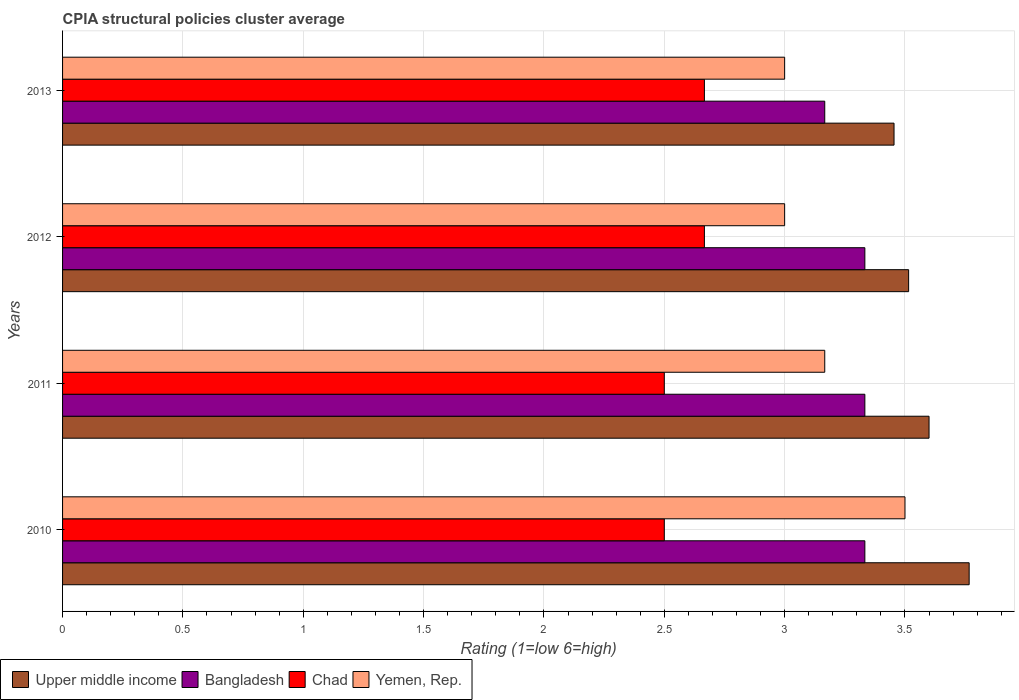How many different coloured bars are there?
Your answer should be compact. 4. How many bars are there on the 4th tick from the bottom?
Provide a succinct answer. 4. What is the label of the 2nd group of bars from the top?
Ensure brevity in your answer.  2012. What is the CPIA rating in Upper middle income in 2013?
Provide a succinct answer. 3.45. Across all years, what is the maximum CPIA rating in Yemen, Rep.?
Your response must be concise. 3.5. Across all years, what is the minimum CPIA rating in Yemen, Rep.?
Your answer should be compact. 3. In which year was the CPIA rating in Yemen, Rep. minimum?
Your answer should be compact. 2012. What is the total CPIA rating in Yemen, Rep. in the graph?
Offer a terse response. 12.67. What is the difference between the CPIA rating in Chad in 2010 and that in 2013?
Keep it short and to the point. -0.17. What is the difference between the CPIA rating in Bangladesh in 2013 and the CPIA rating in Chad in 2012?
Give a very brief answer. 0.5. What is the average CPIA rating in Yemen, Rep. per year?
Make the answer very short. 3.17. In the year 2011, what is the difference between the CPIA rating in Upper middle income and CPIA rating in Chad?
Keep it short and to the point. 1.1. What is the ratio of the CPIA rating in Upper middle income in 2010 to that in 2013?
Offer a terse response. 1.09. Is the CPIA rating in Chad in 2011 less than that in 2012?
Your answer should be very brief. Yes. What is the difference between the highest and the second highest CPIA rating in Chad?
Provide a short and direct response. 0. What is the difference between the highest and the lowest CPIA rating in Bangladesh?
Provide a succinct answer. 0.17. Is the sum of the CPIA rating in Bangladesh in 2012 and 2013 greater than the maximum CPIA rating in Chad across all years?
Ensure brevity in your answer.  Yes. What does the 1st bar from the top in 2010 represents?
Offer a very short reply. Yemen, Rep. Are all the bars in the graph horizontal?
Your response must be concise. Yes. How many years are there in the graph?
Your answer should be very brief. 4. How are the legend labels stacked?
Give a very brief answer. Horizontal. What is the title of the graph?
Offer a very short reply. CPIA structural policies cluster average. Does "Botswana" appear as one of the legend labels in the graph?
Your response must be concise. No. What is the label or title of the X-axis?
Make the answer very short. Rating (1=low 6=high). What is the Rating (1=low 6=high) in Upper middle income in 2010?
Your answer should be compact. 3.77. What is the Rating (1=low 6=high) of Bangladesh in 2010?
Make the answer very short. 3.33. What is the Rating (1=low 6=high) in Chad in 2010?
Provide a succinct answer. 2.5. What is the Rating (1=low 6=high) of Upper middle income in 2011?
Give a very brief answer. 3.6. What is the Rating (1=low 6=high) in Bangladesh in 2011?
Make the answer very short. 3.33. What is the Rating (1=low 6=high) in Chad in 2011?
Offer a terse response. 2.5. What is the Rating (1=low 6=high) in Yemen, Rep. in 2011?
Ensure brevity in your answer.  3.17. What is the Rating (1=low 6=high) of Upper middle income in 2012?
Your response must be concise. 3.52. What is the Rating (1=low 6=high) in Bangladesh in 2012?
Make the answer very short. 3.33. What is the Rating (1=low 6=high) in Chad in 2012?
Your answer should be compact. 2.67. What is the Rating (1=low 6=high) in Yemen, Rep. in 2012?
Provide a succinct answer. 3. What is the Rating (1=low 6=high) of Upper middle income in 2013?
Your response must be concise. 3.45. What is the Rating (1=low 6=high) of Bangladesh in 2013?
Ensure brevity in your answer.  3.17. What is the Rating (1=low 6=high) in Chad in 2013?
Offer a terse response. 2.67. What is the Rating (1=low 6=high) in Yemen, Rep. in 2013?
Keep it short and to the point. 3. Across all years, what is the maximum Rating (1=low 6=high) of Upper middle income?
Provide a succinct answer. 3.77. Across all years, what is the maximum Rating (1=low 6=high) of Bangladesh?
Your response must be concise. 3.33. Across all years, what is the maximum Rating (1=low 6=high) in Chad?
Ensure brevity in your answer.  2.67. Across all years, what is the minimum Rating (1=low 6=high) in Upper middle income?
Offer a very short reply. 3.45. Across all years, what is the minimum Rating (1=low 6=high) in Bangladesh?
Provide a succinct answer. 3.17. Across all years, what is the minimum Rating (1=low 6=high) of Chad?
Offer a terse response. 2.5. What is the total Rating (1=low 6=high) of Upper middle income in the graph?
Keep it short and to the point. 14.34. What is the total Rating (1=low 6=high) in Bangladesh in the graph?
Offer a terse response. 13.17. What is the total Rating (1=low 6=high) in Chad in the graph?
Ensure brevity in your answer.  10.33. What is the total Rating (1=low 6=high) of Yemen, Rep. in the graph?
Keep it short and to the point. 12.67. What is the difference between the Rating (1=low 6=high) of Yemen, Rep. in 2010 and that in 2011?
Keep it short and to the point. 0.33. What is the difference between the Rating (1=low 6=high) of Upper middle income in 2010 and that in 2012?
Make the answer very short. 0.25. What is the difference between the Rating (1=low 6=high) of Bangladesh in 2010 and that in 2012?
Your answer should be compact. 0. What is the difference between the Rating (1=low 6=high) in Chad in 2010 and that in 2012?
Offer a terse response. -0.17. What is the difference between the Rating (1=low 6=high) in Yemen, Rep. in 2010 and that in 2012?
Provide a succinct answer. 0.5. What is the difference between the Rating (1=low 6=high) of Upper middle income in 2010 and that in 2013?
Make the answer very short. 0.31. What is the difference between the Rating (1=low 6=high) of Bangladesh in 2010 and that in 2013?
Make the answer very short. 0.17. What is the difference between the Rating (1=low 6=high) of Upper middle income in 2011 and that in 2012?
Offer a terse response. 0.08. What is the difference between the Rating (1=low 6=high) of Chad in 2011 and that in 2012?
Provide a short and direct response. -0.17. What is the difference between the Rating (1=low 6=high) in Yemen, Rep. in 2011 and that in 2012?
Provide a short and direct response. 0.17. What is the difference between the Rating (1=low 6=high) in Upper middle income in 2011 and that in 2013?
Your answer should be very brief. 0.15. What is the difference between the Rating (1=low 6=high) in Chad in 2011 and that in 2013?
Give a very brief answer. -0.17. What is the difference between the Rating (1=low 6=high) of Yemen, Rep. in 2011 and that in 2013?
Give a very brief answer. 0.17. What is the difference between the Rating (1=low 6=high) in Upper middle income in 2012 and that in 2013?
Your answer should be compact. 0.06. What is the difference between the Rating (1=low 6=high) of Bangladesh in 2012 and that in 2013?
Your answer should be very brief. 0.17. What is the difference between the Rating (1=low 6=high) of Chad in 2012 and that in 2013?
Offer a very short reply. 0. What is the difference between the Rating (1=low 6=high) in Yemen, Rep. in 2012 and that in 2013?
Your answer should be very brief. 0. What is the difference between the Rating (1=low 6=high) in Upper middle income in 2010 and the Rating (1=low 6=high) in Bangladesh in 2011?
Your response must be concise. 0.43. What is the difference between the Rating (1=low 6=high) of Upper middle income in 2010 and the Rating (1=low 6=high) of Chad in 2011?
Your answer should be very brief. 1.27. What is the difference between the Rating (1=low 6=high) of Upper middle income in 2010 and the Rating (1=low 6=high) of Yemen, Rep. in 2011?
Your answer should be very brief. 0.6. What is the difference between the Rating (1=low 6=high) of Bangladesh in 2010 and the Rating (1=low 6=high) of Chad in 2011?
Your answer should be very brief. 0.83. What is the difference between the Rating (1=low 6=high) in Upper middle income in 2010 and the Rating (1=low 6=high) in Bangladesh in 2012?
Your answer should be very brief. 0.43. What is the difference between the Rating (1=low 6=high) in Upper middle income in 2010 and the Rating (1=low 6=high) in Chad in 2012?
Provide a succinct answer. 1.1. What is the difference between the Rating (1=low 6=high) in Upper middle income in 2010 and the Rating (1=low 6=high) in Yemen, Rep. in 2012?
Your answer should be compact. 0.77. What is the difference between the Rating (1=low 6=high) in Bangladesh in 2010 and the Rating (1=low 6=high) in Yemen, Rep. in 2012?
Your answer should be compact. 0.33. What is the difference between the Rating (1=low 6=high) of Upper middle income in 2010 and the Rating (1=low 6=high) of Bangladesh in 2013?
Keep it short and to the point. 0.6. What is the difference between the Rating (1=low 6=high) in Upper middle income in 2010 and the Rating (1=low 6=high) in Chad in 2013?
Keep it short and to the point. 1.1. What is the difference between the Rating (1=low 6=high) in Upper middle income in 2010 and the Rating (1=low 6=high) in Yemen, Rep. in 2013?
Provide a short and direct response. 0.77. What is the difference between the Rating (1=low 6=high) in Bangladesh in 2010 and the Rating (1=low 6=high) in Chad in 2013?
Offer a terse response. 0.67. What is the difference between the Rating (1=low 6=high) in Chad in 2010 and the Rating (1=low 6=high) in Yemen, Rep. in 2013?
Keep it short and to the point. -0.5. What is the difference between the Rating (1=low 6=high) of Upper middle income in 2011 and the Rating (1=low 6=high) of Bangladesh in 2012?
Offer a terse response. 0.27. What is the difference between the Rating (1=low 6=high) in Upper middle income in 2011 and the Rating (1=low 6=high) in Yemen, Rep. in 2012?
Ensure brevity in your answer.  0.6. What is the difference between the Rating (1=low 6=high) of Bangladesh in 2011 and the Rating (1=low 6=high) of Chad in 2012?
Keep it short and to the point. 0.67. What is the difference between the Rating (1=low 6=high) in Bangladesh in 2011 and the Rating (1=low 6=high) in Yemen, Rep. in 2012?
Make the answer very short. 0.33. What is the difference between the Rating (1=low 6=high) of Chad in 2011 and the Rating (1=low 6=high) of Yemen, Rep. in 2012?
Give a very brief answer. -0.5. What is the difference between the Rating (1=low 6=high) of Upper middle income in 2011 and the Rating (1=low 6=high) of Bangladesh in 2013?
Keep it short and to the point. 0.43. What is the difference between the Rating (1=low 6=high) in Upper middle income in 2011 and the Rating (1=low 6=high) in Chad in 2013?
Provide a succinct answer. 0.93. What is the difference between the Rating (1=low 6=high) in Upper middle income in 2012 and the Rating (1=low 6=high) in Bangladesh in 2013?
Keep it short and to the point. 0.35. What is the difference between the Rating (1=low 6=high) in Upper middle income in 2012 and the Rating (1=low 6=high) in Chad in 2013?
Provide a succinct answer. 0.85. What is the difference between the Rating (1=low 6=high) of Upper middle income in 2012 and the Rating (1=low 6=high) of Yemen, Rep. in 2013?
Your response must be concise. 0.52. What is the difference between the Rating (1=low 6=high) of Bangladesh in 2012 and the Rating (1=low 6=high) of Yemen, Rep. in 2013?
Offer a very short reply. 0.33. What is the difference between the Rating (1=low 6=high) in Chad in 2012 and the Rating (1=low 6=high) in Yemen, Rep. in 2013?
Provide a succinct answer. -0.33. What is the average Rating (1=low 6=high) of Upper middle income per year?
Provide a short and direct response. 3.58. What is the average Rating (1=low 6=high) in Bangladesh per year?
Your answer should be compact. 3.29. What is the average Rating (1=low 6=high) in Chad per year?
Provide a succinct answer. 2.58. What is the average Rating (1=low 6=high) of Yemen, Rep. per year?
Offer a very short reply. 3.17. In the year 2010, what is the difference between the Rating (1=low 6=high) of Upper middle income and Rating (1=low 6=high) of Bangladesh?
Give a very brief answer. 0.43. In the year 2010, what is the difference between the Rating (1=low 6=high) of Upper middle income and Rating (1=low 6=high) of Chad?
Your response must be concise. 1.27. In the year 2010, what is the difference between the Rating (1=low 6=high) in Upper middle income and Rating (1=low 6=high) in Yemen, Rep.?
Your answer should be compact. 0.27. In the year 2011, what is the difference between the Rating (1=low 6=high) of Upper middle income and Rating (1=low 6=high) of Bangladesh?
Provide a short and direct response. 0.27. In the year 2011, what is the difference between the Rating (1=low 6=high) in Upper middle income and Rating (1=low 6=high) in Chad?
Offer a very short reply. 1.1. In the year 2011, what is the difference between the Rating (1=low 6=high) in Upper middle income and Rating (1=low 6=high) in Yemen, Rep.?
Give a very brief answer. 0.43. In the year 2012, what is the difference between the Rating (1=low 6=high) of Upper middle income and Rating (1=low 6=high) of Bangladesh?
Your answer should be very brief. 0.18. In the year 2012, what is the difference between the Rating (1=low 6=high) in Upper middle income and Rating (1=low 6=high) in Chad?
Offer a terse response. 0.85. In the year 2012, what is the difference between the Rating (1=low 6=high) in Upper middle income and Rating (1=low 6=high) in Yemen, Rep.?
Your answer should be compact. 0.52. In the year 2012, what is the difference between the Rating (1=low 6=high) of Bangladesh and Rating (1=low 6=high) of Yemen, Rep.?
Give a very brief answer. 0.33. In the year 2013, what is the difference between the Rating (1=low 6=high) of Upper middle income and Rating (1=low 6=high) of Bangladesh?
Your answer should be very brief. 0.29. In the year 2013, what is the difference between the Rating (1=low 6=high) in Upper middle income and Rating (1=low 6=high) in Chad?
Your answer should be compact. 0.79. In the year 2013, what is the difference between the Rating (1=low 6=high) in Upper middle income and Rating (1=low 6=high) in Yemen, Rep.?
Your answer should be compact. 0.45. In the year 2013, what is the difference between the Rating (1=low 6=high) of Bangladesh and Rating (1=low 6=high) of Chad?
Provide a succinct answer. 0.5. What is the ratio of the Rating (1=low 6=high) in Upper middle income in 2010 to that in 2011?
Your answer should be very brief. 1.05. What is the ratio of the Rating (1=low 6=high) in Chad in 2010 to that in 2011?
Your response must be concise. 1. What is the ratio of the Rating (1=low 6=high) of Yemen, Rep. in 2010 to that in 2011?
Your answer should be compact. 1.11. What is the ratio of the Rating (1=low 6=high) of Upper middle income in 2010 to that in 2012?
Offer a terse response. 1.07. What is the ratio of the Rating (1=low 6=high) of Upper middle income in 2010 to that in 2013?
Provide a succinct answer. 1.09. What is the ratio of the Rating (1=low 6=high) of Bangladesh in 2010 to that in 2013?
Give a very brief answer. 1.05. What is the ratio of the Rating (1=low 6=high) in Upper middle income in 2011 to that in 2012?
Provide a succinct answer. 1.02. What is the ratio of the Rating (1=low 6=high) in Bangladesh in 2011 to that in 2012?
Provide a succinct answer. 1. What is the ratio of the Rating (1=low 6=high) in Chad in 2011 to that in 2012?
Provide a short and direct response. 0.94. What is the ratio of the Rating (1=low 6=high) of Yemen, Rep. in 2011 to that in 2012?
Your answer should be very brief. 1.06. What is the ratio of the Rating (1=low 6=high) of Upper middle income in 2011 to that in 2013?
Provide a succinct answer. 1.04. What is the ratio of the Rating (1=low 6=high) of Bangladesh in 2011 to that in 2013?
Give a very brief answer. 1.05. What is the ratio of the Rating (1=low 6=high) in Yemen, Rep. in 2011 to that in 2013?
Your answer should be very brief. 1.06. What is the ratio of the Rating (1=low 6=high) of Upper middle income in 2012 to that in 2013?
Your answer should be very brief. 1.02. What is the ratio of the Rating (1=low 6=high) of Bangladesh in 2012 to that in 2013?
Your answer should be compact. 1.05. What is the ratio of the Rating (1=low 6=high) in Chad in 2012 to that in 2013?
Offer a terse response. 1. What is the ratio of the Rating (1=low 6=high) of Yemen, Rep. in 2012 to that in 2013?
Your response must be concise. 1. What is the difference between the highest and the second highest Rating (1=low 6=high) of Bangladesh?
Your response must be concise. 0. What is the difference between the highest and the second highest Rating (1=low 6=high) in Chad?
Ensure brevity in your answer.  0. What is the difference between the highest and the lowest Rating (1=low 6=high) in Upper middle income?
Provide a short and direct response. 0.31. 